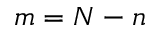Convert formula to latex. <formula><loc_0><loc_0><loc_500><loc_500>m = N - n</formula> 